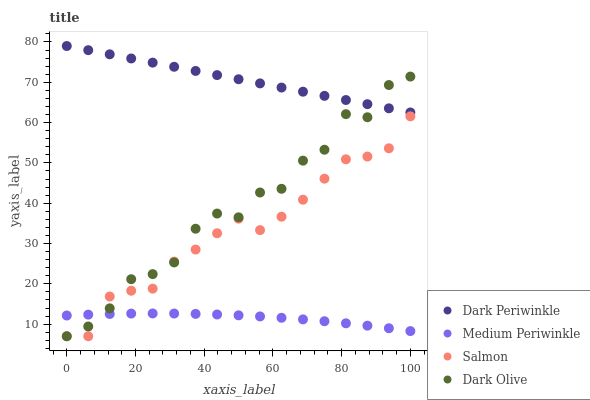Does Medium Periwinkle have the minimum area under the curve?
Answer yes or no. Yes. Does Dark Periwinkle have the maximum area under the curve?
Answer yes or no. Yes. Does Dark Olive have the minimum area under the curve?
Answer yes or no. No. Does Dark Olive have the maximum area under the curve?
Answer yes or no. No. Is Dark Periwinkle the smoothest?
Answer yes or no. Yes. Is Dark Olive the roughest?
Answer yes or no. Yes. Is Medium Periwinkle the smoothest?
Answer yes or no. No. Is Medium Periwinkle the roughest?
Answer yes or no. No. Does Salmon have the lowest value?
Answer yes or no. Yes. Does Medium Periwinkle have the lowest value?
Answer yes or no. No. Does Dark Periwinkle have the highest value?
Answer yes or no. Yes. Does Dark Olive have the highest value?
Answer yes or no. No. Is Salmon less than Dark Periwinkle?
Answer yes or no. Yes. Is Dark Periwinkle greater than Salmon?
Answer yes or no. Yes. Does Dark Olive intersect Medium Periwinkle?
Answer yes or no. Yes. Is Dark Olive less than Medium Periwinkle?
Answer yes or no. No. Is Dark Olive greater than Medium Periwinkle?
Answer yes or no. No. Does Salmon intersect Dark Periwinkle?
Answer yes or no. No. 